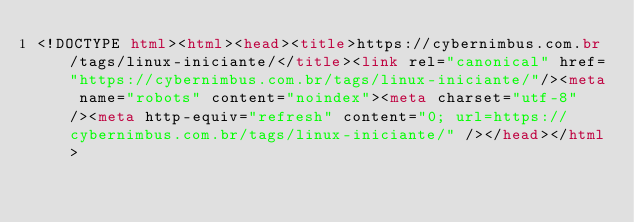Convert code to text. <code><loc_0><loc_0><loc_500><loc_500><_HTML_><!DOCTYPE html><html><head><title>https://cybernimbus.com.br/tags/linux-iniciante/</title><link rel="canonical" href="https://cybernimbus.com.br/tags/linux-iniciante/"/><meta name="robots" content="noindex"><meta charset="utf-8" /><meta http-equiv="refresh" content="0; url=https://cybernimbus.com.br/tags/linux-iniciante/" /></head></html></code> 